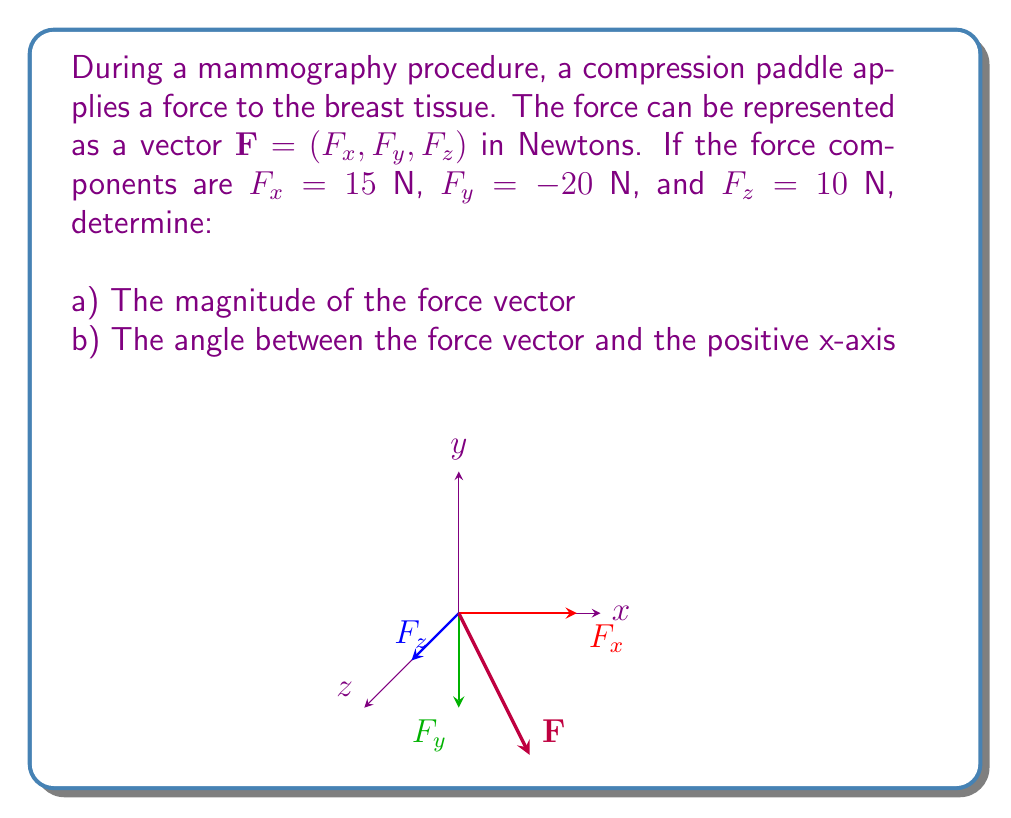Help me with this question. Let's approach this step-by-step:

a) To find the magnitude of the force vector, we use the formula:

$$|\mathbf{F}| = \sqrt{F_x^2 + F_y^2 + F_z^2}$$

Substituting the given values:

$$|\mathbf{F}| = \sqrt{15^2 + (-20)^2 + 10^2}$$
$$|\mathbf{F}| = \sqrt{225 + 400 + 100}$$
$$|\mathbf{F}| = \sqrt{725}$$
$$|\mathbf{F}| \approx 26.93 \text{ N}$$

b) To find the angle between the force vector and the positive x-axis, we can use the dot product formula:

$$\cos \theta = \frac{\mathbf{F} \cdot \mathbf{i}}{|\mathbf{F}||\mathbf{i}|}$$

Where $\mathbf{i}$ is the unit vector in the x-direction $(1,0,0)$.

$$\cos \theta = \frac{F_x}{|\mathbf{F}|}$$

$$\theta = \arccos(\frac{F_x}{|\mathbf{F}|})$$

Substituting the values:

$$\theta = \arccos(\frac{15}{26.93})$$
$$\theta \approx 0.8391 \text{ radians}$$

Converting to degrees:

$$\theta \approx 48.10°$$
Answer: a) $26.93 \text{ N}$
b) $48.10°$ 